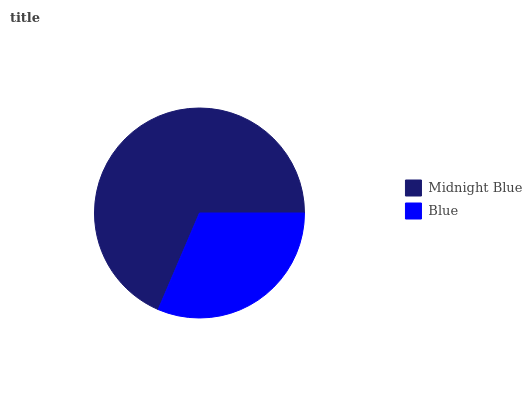Is Blue the minimum?
Answer yes or no. Yes. Is Midnight Blue the maximum?
Answer yes or no. Yes. Is Blue the maximum?
Answer yes or no. No. Is Midnight Blue greater than Blue?
Answer yes or no. Yes. Is Blue less than Midnight Blue?
Answer yes or no. Yes. Is Blue greater than Midnight Blue?
Answer yes or no. No. Is Midnight Blue less than Blue?
Answer yes or no. No. Is Midnight Blue the high median?
Answer yes or no. Yes. Is Blue the low median?
Answer yes or no. Yes. Is Blue the high median?
Answer yes or no. No. Is Midnight Blue the low median?
Answer yes or no. No. 